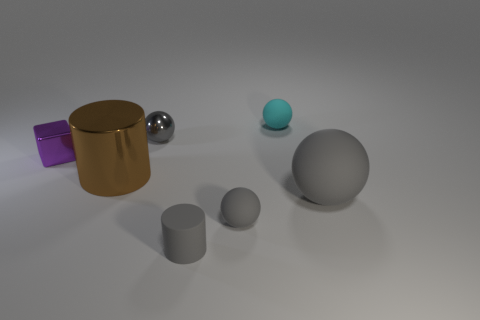Subtract all cylinders. How many objects are left? 5 Subtract 1 blocks. How many blocks are left? 0 Subtract all gray blocks. Subtract all cyan cylinders. How many blocks are left? 1 Subtract all brown cylinders. How many gray spheres are left? 3 Subtract all small metal things. Subtract all balls. How many objects are left? 1 Add 3 tiny gray shiny things. How many tiny gray shiny things are left? 4 Add 1 small metallic balls. How many small metallic balls exist? 2 Add 2 purple metal blocks. How many objects exist? 9 Subtract all brown cylinders. How many cylinders are left? 1 Subtract all big gray matte spheres. How many spheres are left? 3 